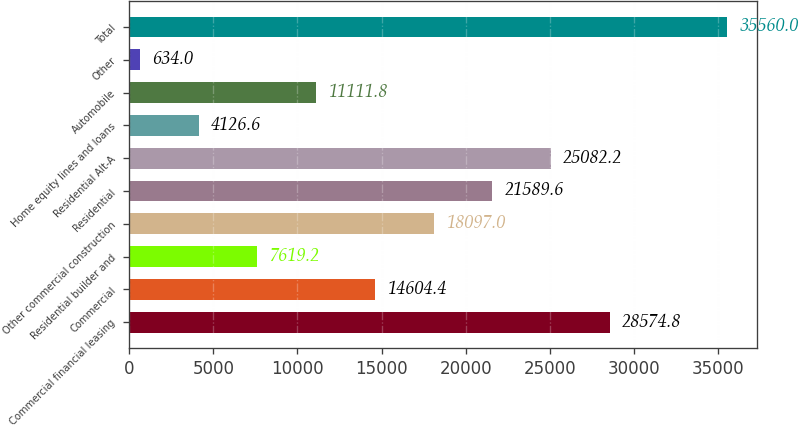Convert chart to OTSL. <chart><loc_0><loc_0><loc_500><loc_500><bar_chart><fcel>Commercial financial leasing<fcel>Commercial<fcel>Residential builder and<fcel>Other commercial construction<fcel>Residential<fcel>Residential Alt-A<fcel>Home equity lines and loans<fcel>Automobile<fcel>Other<fcel>Total<nl><fcel>28574.8<fcel>14604.4<fcel>7619.2<fcel>18097<fcel>21589.6<fcel>25082.2<fcel>4126.6<fcel>11111.8<fcel>634<fcel>35560<nl></chart> 